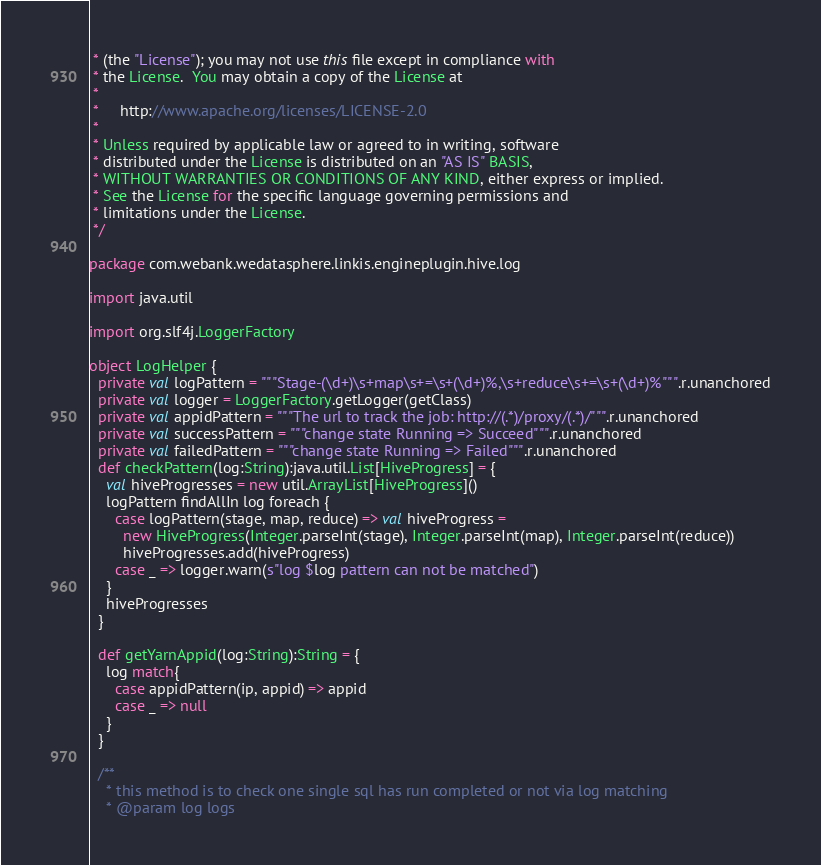<code> <loc_0><loc_0><loc_500><loc_500><_Scala_> * (the "License"); you may not use this file except in compliance with
 * the License.  You may obtain a copy of the License at
 *
 *     http://www.apache.org/licenses/LICENSE-2.0
 *
 * Unless required by applicable law or agreed to in writing, software
 * distributed under the License is distributed on an "AS IS" BASIS,
 * WITHOUT WARRANTIES OR CONDITIONS OF ANY KIND, either express or implied.
 * See the License for the specific language governing permissions and
 * limitations under the License.
 */

package com.webank.wedatasphere.linkis.engineplugin.hive.log

import java.util

import org.slf4j.LoggerFactory

object LogHelper {
  private val logPattern = """Stage-(\d+)\s+map\s+=\s+(\d+)%,\s+reduce\s+=\s+(\d+)%""".r.unanchored
  private val logger = LoggerFactory.getLogger(getClass)
  private val appidPattern = """The url to track the job: http://(.*)/proxy/(.*)/""".r.unanchored
  private val successPattern = """change state Running => Succeed""".r.unanchored
  private val failedPattern = """change state Running => Failed""".r.unanchored
  def checkPattern(log:String):java.util.List[HiveProgress] = {
    val hiveProgresses = new util.ArrayList[HiveProgress]()
    logPattern findAllIn log foreach {
      case logPattern(stage, map, reduce) => val hiveProgress =
        new HiveProgress(Integer.parseInt(stage), Integer.parseInt(map), Integer.parseInt(reduce))
        hiveProgresses.add(hiveProgress)
      case _ => logger.warn(s"log $log pattern can not be matched")
    }
    hiveProgresses
  }

  def getYarnAppid(log:String):String = {
    log match{
      case appidPattern(ip, appid) => appid
      case _ => null
    }
  }

  /**
    * this method is to check one single sql has run completed or not via log matching
    * @param log logs</code> 